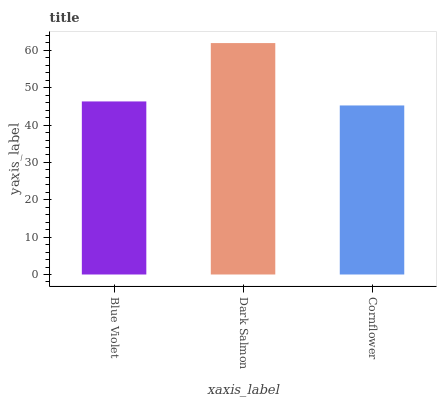Is Dark Salmon the minimum?
Answer yes or no. No. Is Cornflower the maximum?
Answer yes or no. No. Is Dark Salmon greater than Cornflower?
Answer yes or no. Yes. Is Cornflower less than Dark Salmon?
Answer yes or no. Yes. Is Cornflower greater than Dark Salmon?
Answer yes or no. No. Is Dark Salmon less than Cornflower?
Answer yes or no. No. Is Blue Violet the high median?
Answer yes or no. Yes. Is Blue Violet the low median?
Answer yes or no. Yes. Is Cornflower the high median?
Answer yes or no. No. Is Dark Salmon the low median?
Answer yes or no. No. 